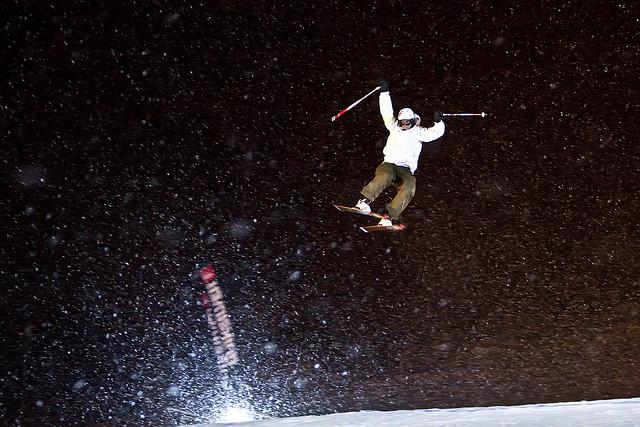Does the skier have a hat or hood on his/her head?
Concise answer only. Yes. Does this skier have both poles?
Concise answer only. Yes. Why is he jumping so high?
Short answer required. Ski jump. 